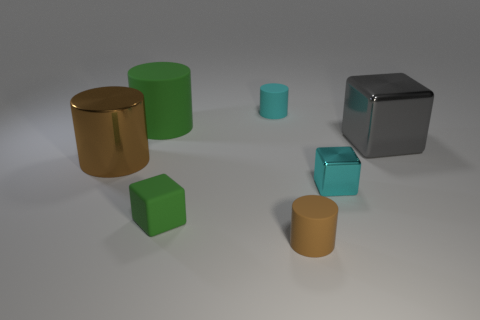How many other things are the same shape as the brown metallic thing?
Provide a succinct answer. 3. There is a cyan object that is right of the tiny cyan matte thing; is it the same shape as the big shiny thing on the right side of the small rubber block?
Provide a succinct answer. Yes. Are there the same number of small metallic blocks right of the gray metallic thing and small brown matte things to the left of the small brown rubber object?
Provide a succinct answer. Yes. There is a big metallic thing that is to the right of the small matte object to the left of the cyan thing behind the brown metallic object; what shape is it?
Make the answer very short. Cube. Do the small cyan thing behind the large cube and the brown cylinder on the left side of the small rubber cube have the same material?
Provide a short and direct response. No. There is a green thing to the left of the rubber block; what is its shape?
Offer a terse response. Cylinder. Is the number of matte cylinders less than the number of cyan matte cylinders?
Your answer should be very brief. No. There is a small block to the left of the brown cylinder in front of the big brown thing; is there a big shiny thing that is on the left side of it?
Provide a succinct answer. Yes. What number of metal things are tiny green spheres or large cylinders?
Your answer should be very brief. 1. Do the rubber cube and the large rubber object have the same color?
Offer a very short reply. Yes. 